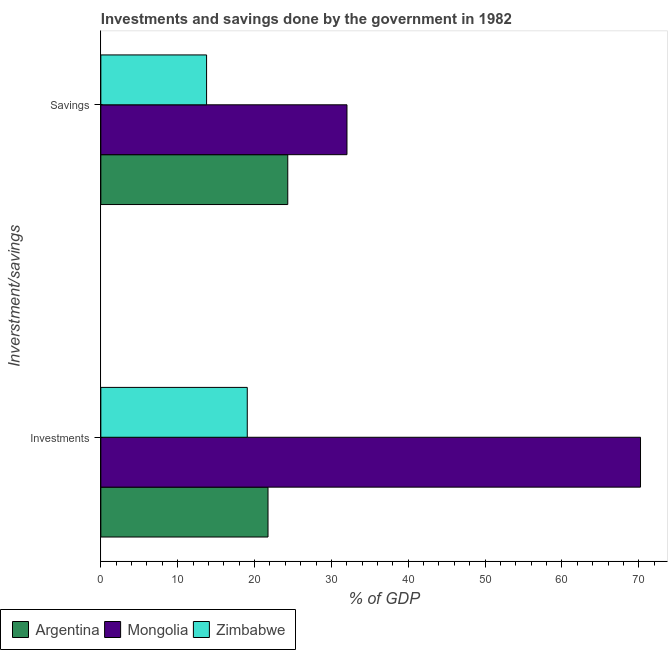How many different coloured bars are there?
Keep it short and to the point. 3. How many groups of bars are there?
Your answer should be compact. 2. Are the number of bars per tick equal to the number of legend labels?
Provide a short and direct response. Yes. Are the number of bars on each tick of the Y-axis equal?
Keep it short and to the point. Yes. How many bars are there on the 1st tick from the top?
Your answer should be compact. 3. How many bars are there on the 2nd tick from the bottom?
Give a very brief answer. 3. What is the label of the 1st group of bars from the top?
Ensure brevity in your answer.  Savings. What is the investments of government in Argentina?
Provide a short and direct response. 21.75. Across all countries, what is the maximum savings of government?
Keep it short and to the point. 32.03. Across all countries, what is the minimum savings of government?
Keep it short and to the point. 13.76. In which country was the savings of government maximum?
Your response must be concise. Mongolia. In which country was the investments of government minimum?
Give a very brief answer. Zimbabwe. What is the total investments of government in the graph?
Your response must be concise. 111.04. What is the difference between the savings of government in Argentina and that in Mongolia?
Your answer should be compact. -7.71. What is the difference between the savings of government in Zimbabwe and the investments of government in Argentina?
Make the answer very short. -8. What is the average investments of government per country?
Provide a short and direct response. 37.01. What is the difference between the investments of government and savings of government in Zimbabwe?
Your response must be concise. 5.29. In how many countries, is the investments of government greater than 34 %?
Your answer should be very brief. 1. What is the ratio of the investments of government in Argentina to that in Zimbabwe?
Make the answer very short. 1.14. Is the savings of government in Mongolia less than that in Zimbabwe?
Offer a very short reply. No. In how many countries, is the investments of government greater than the average investments of government taken over all countries?
Offer a very short reply. 1. What does the 2nd bar from the top in Savings represents?
Make the answer very short. Mongolia. What does the 3rd bar from the bottom in Investments represents?
Give a very brief answer. Zimbabwe. How many bars are there?
Offer a very short reply. 6. Are the values on the major ticks of X-axis written in scientific E-notation?
Your answer should be very brief. No. Does the graph contain grids?
Provide a succinct answer. No. Where does the legend appear in the graph?
Offer a terse response. Bottom left. What is the title of the graph?
Provide a succinct answer. Investments and savings done by the government in 1982. Does "Sint Maarten (Dutch part)" appear as one of the legend labels in the graph?
Provide a short and direct response. No. What is the label or title of the X-axis?
Ensure brevity in your answer.  % of GDP. What is the label or title of the Y-axis?
Provide a short and direct response. Inverstment/savings. What is the % of GDP of Argentina in Investments?
Your response must be concise. 21.75. What is the % of GDP in Mongolia in Investments?
Your answer should be very brief. 70.23. What is the % of GDP in Zimbabwe in Investments?
Provide a succinct answer. 19.05. What is the % of GDP of Argentina in Savings?
Provide a short and direct response. 24.32. What is the % of GDP in Mongolia in Savings?
Make the answer very short. 32.03. What is the % of GDP in Zimbabwe in Savings?
Keep it short and to the point. 13.76. Across all Inverstment/savings, what is the maximum % of GDP of Argentina?
Offer a terse response. 24.32. Across all Inverstment/savings, what is the maximum % of GDP in Mongolia?
Make the answer very short. 70.23. Across all Inverstment/savings, what is the maximum % of GDP of Zimbabwe?
Provide a succinct answer. 19.05. Across all Inverstment/savings, what is the minimum % of GDP in Argentina?
Ensure brevity in your answer.  21.75. Across all Inverstment/savings, what is the minimum % of GDP in Mongolia?
Offer a terse response. 32.03. Across all Inverstment/savings, what is the minimum % of GDP of Zimbabwe?
Ensure brevity in your answer.  13.76. What is the total % of GDP of Argentina in the graph?
Offer a terse response. 46.08. What is the total % of GDP in Mongolia in the graph?
Offer a very short reply. 102.26. What is the total % of GDP of Zimbabwe in the graph?
Ensure brevity in your answer.  32.81. What is the difference between the % of GDP in Argentina in Investments and that in Savings?
Provide a succinct answer. -2.57. What is the difference between the % of GDP in Mongolia in Investments and that in Savings?
Make the answer very short. 38.2. What is the difference between the % of GDP in Zimbabwe in Investments and that in Savings?
Ensure brevity in your answer.  5.29. What is the difference between the % of GDP of Argentina in Investments and the % of GDP of Mongolia in Savings?
Ensure brevity in your answer.  -10.28. What is the difference between the % of GDP of Argentina in Investments and the % of GDP of Zimbabwe in Savings?
Ensure brevity in your answer.  8. What is the difference between the % of GDP in Mongolia in Investments and the % of GDP in Zimbabwe in Savings?
Make the answer very short. 56.47. What is the average % of GDP of Argentina per Inverstment/savings?
Make the answer very short. 23.04. What is the average % of GDP of Mongolia per Inverstment/savings?
Your answer should be very brief. 51.13. What is the average % of GDP of Zimbabwe per Inverstment/savings?
Your answer should be very brief. 16.41. What is the difference between the % of GDP of Argentina and % of GDP of Mongolia in Investments?
Offer a very short reply. -48.47. What is the difference between the % of GDP of Argentina and % of GDP of Zimbabwe in Investments?
Your answer should be compact. 2.7. What is the difference between the % of GDP of Mongolia and % of GDP of Zimbabwe in Investments?
Provide a short and direct response. 51.18. What is the difference between the % of GDP of Argentina and % of GDP of Mongolia in Savings?
Make the answer very short. -7.71. What is the difference between the % of GDP of Argentina and % of GDP of Zimbabwe in Savings?
Keep it short and to the point. 10.56. What is the difference between the % of GDP of Mongolia and % of GDP of Zimbabwe in Savings?
Ensure brevity in your answer.  18.27. What is the ratio of the % of GDP of Argentina in Investments to that in Savings?
Your answer should be compact. 0.89. What is the ratio of the % of GDP in Mongolia in Investments to that in Savings?
Keep it short and to the point. 2.19. What is the ratio of the % of GDP of Zimbabwe in Investments to that in Savings?
Your response must be concise. 1.38. What is the difference between the highest and the second highest % of GDP in Argentina?
Ensure brevity in your answer.  2.57. What is the difference between the highest and the second highest % of GDP of Mongolia?
Provide a short and direct response. 38.2. What is the difference between the highest and the second highest % of GDP in Zimbabwe?
Ensure brevity in your answer.  5.29. What is the difference between the highest and the lowest % of GDP of Argentina?
Your answer should be compact. 2.57. What is the difference between the highest and the lowest % of GDP in Mongolia?
Provide a succinct answer. 38.2. What is the difference between the highest and the lowest % of GDP of Zimbabwe?
Keep it short and to the point. 5.29. 